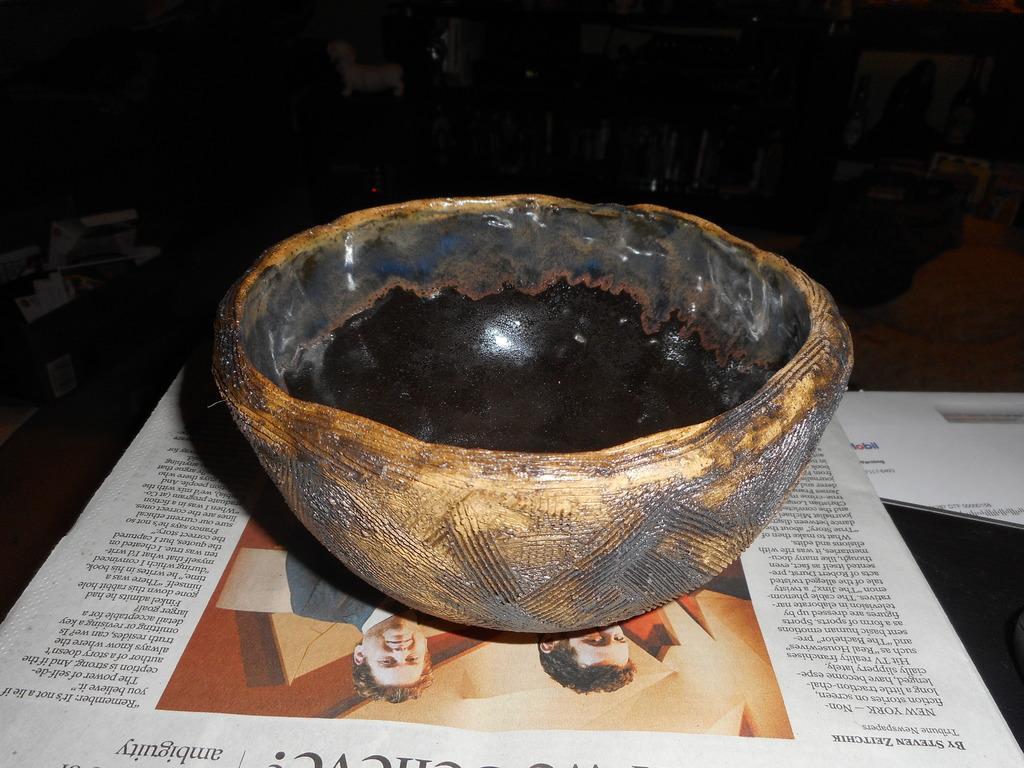Describe this image in one or two sentences. Background portion of the picture is completely dark and we can see the few objects, it seems like a dog. This picture is mainly highlighted with a black bowl placed on the newspaper and we can see another paper. 